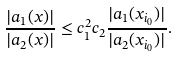Convert formula to latex. <formula><loc_0><loc_0><loc_500><loc_500>\frac { | a _ { 1 } ( x ) | } { | a _ { 2 } ( x ) | } \leq c _ { 1 } ^ { 2 } c _ { 2 } \frac { | a _ { 1 } ( x _ { i _ { 0 } } ) | } { | a _ { 2 } ( x _ { i _ { 0 } } ) | } .</formula> 